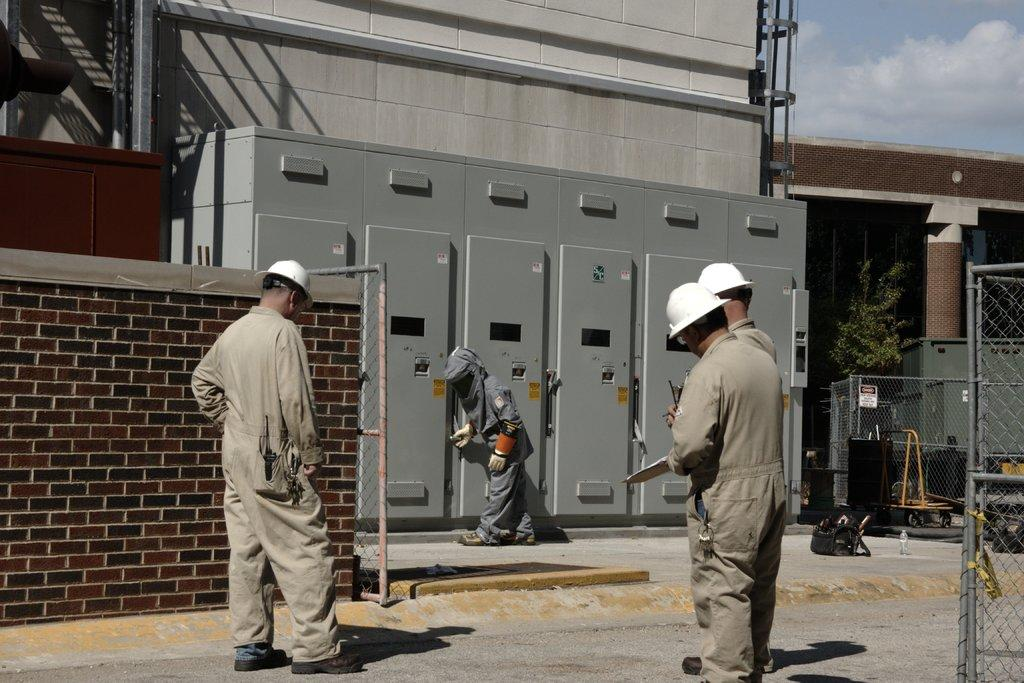What are the people in the image doing? The people in the image are standing on the road. What can be seen in the background of the image? There are buildings visible near the road. Where is the person standing in relation to the electric boards? The person is standing near electric boards. What color is the view from the top of the electric boards? The image does not show a view from the top of the electric boards, nor does it provide any information about the color of such a view. 